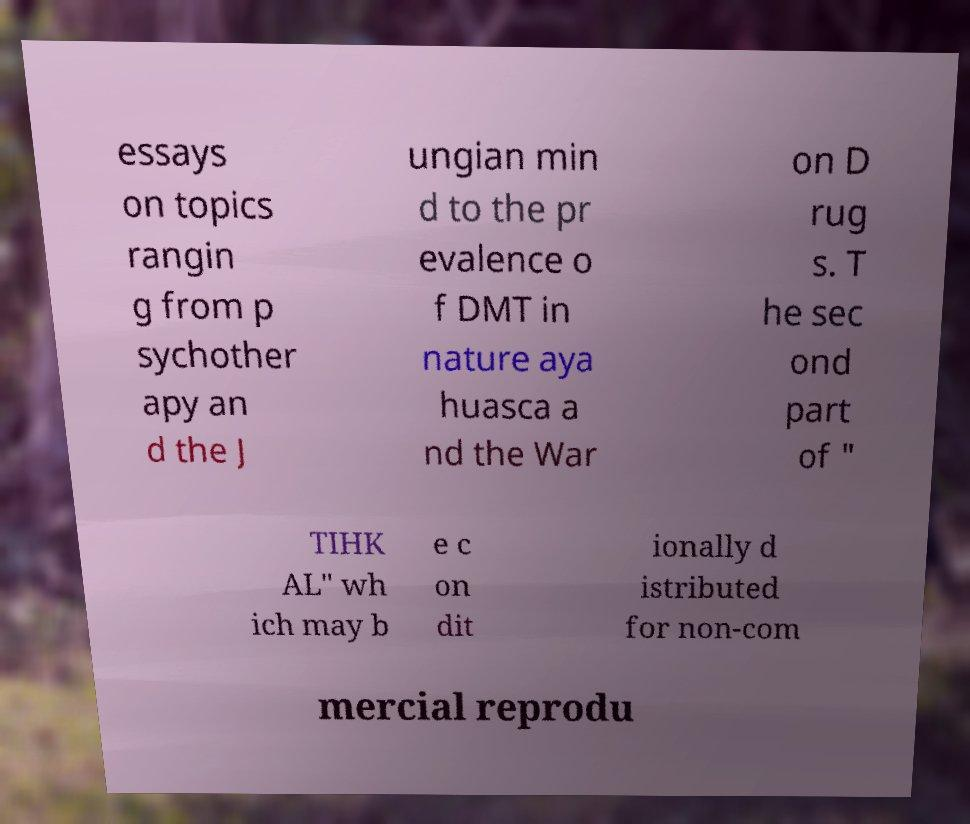Can you accurately transcribe the text from the provided image for me? essays on topics rangin g from p sychother apy an d the J ungian min d to the pr evalence o f DMT in nature aya huasca a nd the War on D rug s. T he sec ond part of " TIHK AL" wh ich may b e c on dit ionally d istributed for non-com mercial reprodu 